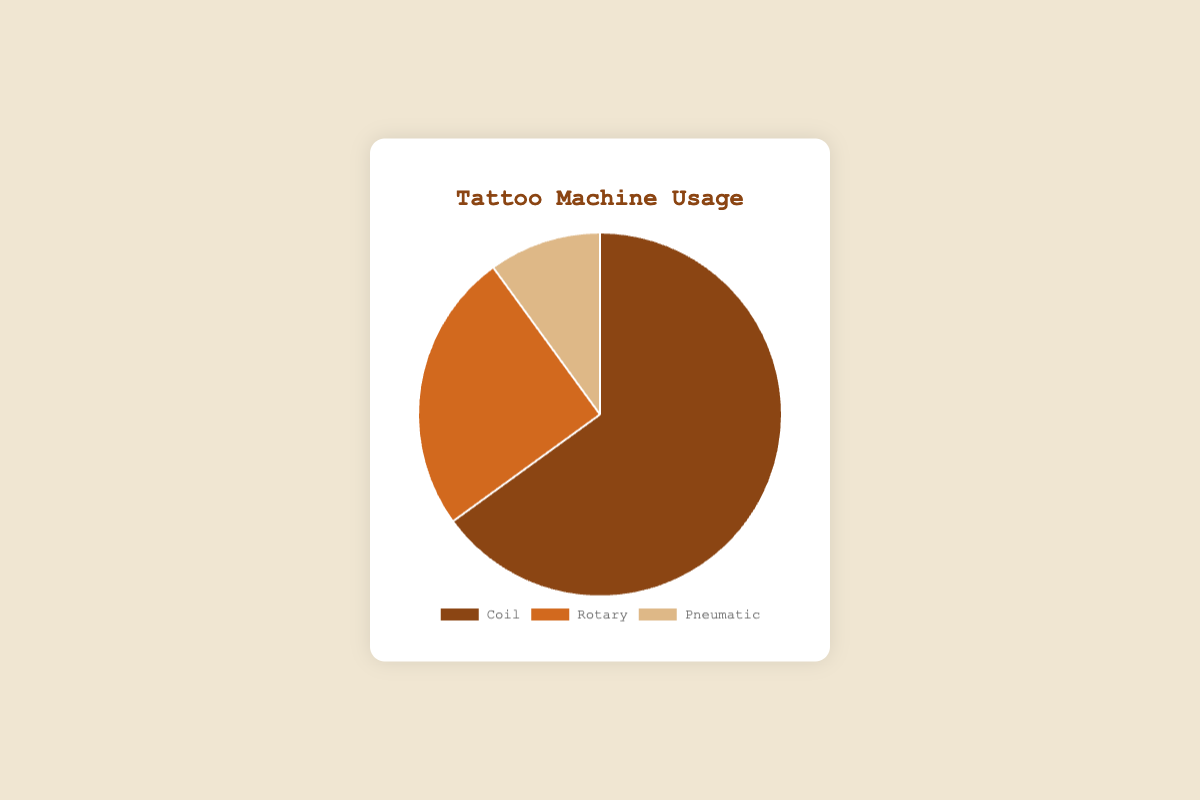What is the most used tattoo machine type? By looking at the pie chart, the segment representing the "Coil" type is the largest. Thus, the "Coil" machine is the most used.
Answer: Coil Which tattoo machine type is the least used? The smallest segment in the pie chart is the one representing the "Pneumatic" type, indicating it is the least used.
Answer: Pneumatic How much greater is the usage of Coil machines compared to Rotary machines? The percentage of Coil machines is 65% and the percentage of Rotary machines is 25%. The difference is calculated as 65% - 25%.
Answer: 40% Which two types of tattoo machines make up 90% of the usage? Adding the percentages of Coil (65%) and Rotary (25%) machines gives a total of 90%. Thus, these two types make up 90% of the usage.
Answer: Coil and Rotary What percentage of usage do the Coil and Pneumatic machines have together? Adding the percentages of Coil (65%) and Pneumatic (10%) machines gives a total usage of 75%.
Answer: 75% By what factor is the Coil machine usage greater than the Pneumatic machine usage? The Coil machine usage is 65% and the Pneumatic machine usage is 10%. Dividing these percentages gives 65 / 10, which results in a factor of 6.5.
Answer: 6.5 Which tattoo machine category color is represented by the darkest shade? By observing the visual colors in the pie chart, the Coil machine segment has the darkest shade compared to Rotary and Pneumatic.
Answer: Coil 